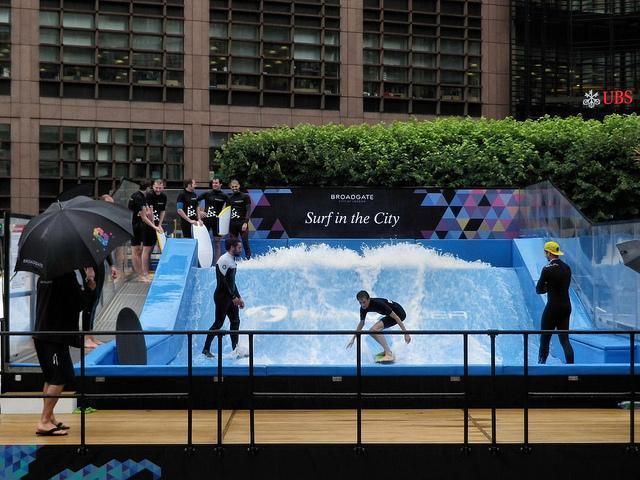What sort of building is seen behind this amusement?
Indicate the correct response by choosing from the four available options to answer the question.
Options: School, barn, cafe, financial. Financial. 